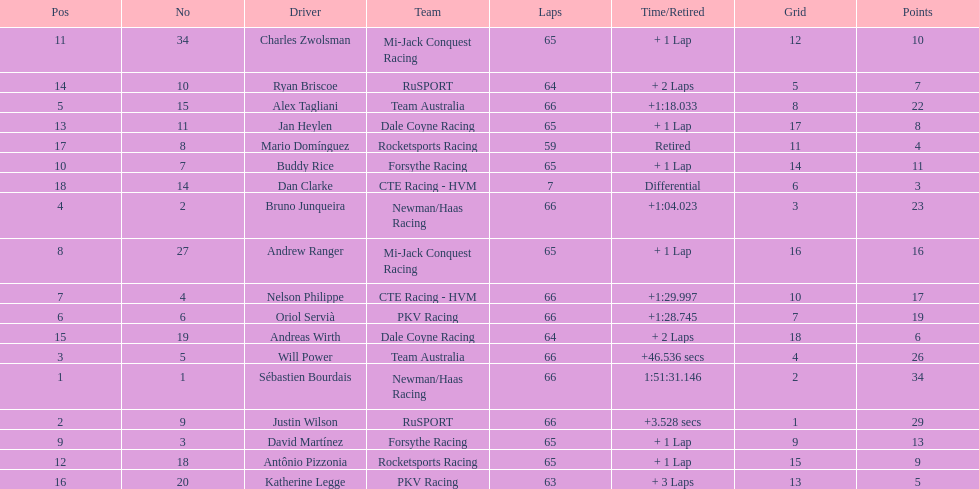Parse the table in full. {'header': ['Pos', 'No', 'Driver', 'Team', 'Laps', 'Time/Retired', 'Grid', 'Points'], 'rows': [['11', '34', 'Charles Zwolsman', 'Mi-Jack Conquest Racing', '65', '+ 1 Lap', '12', '10'], ['14', '10', 'Ryan Briscoe', 'RuSPORT', '64', '+ 2 Laps', '5', '7'], ['5', '15', 'Alex Tagliani', 'Team Australia', '66', '+1:18.033', '8', '22'], ['13', '11', 'Jan Heylen', 'Dale Coyne Racing', '65', '+ 1 Lap', '17', '8'], ['17', '8', 'Mario Domínguez', 'Rocketsports Racing', '59', 'Retired', '11', '4'], ['10', '7', 'Buddy Rice', 'Forsythe Racing', '65', '+ 1 Lap', '14', '11'], ['18', '14', 'Dan Clarke', 'CTE Racing - HVM', '7', 'Differential', '6', '3'], ['4', '2', 'Bruno Junqueira', 'Newman/Haas Racing', '66', '+1:04.023', '3', '23'], ['8', '27', 'Andrew Ranger', 'Mi-Jack Conquest Racing', '65', '+ 1 Lap', '16', '16'], ['7', '4', 'Nelson Philippe', 'CTE Racing - HVM', '66', '+1:29.997', '10', '17'], ['6', '6', 'Oriol Servià', 'PKV Racing', '66', '+1:28.745', '7', '19'], ['15', '19', 'Andreas Wirth', 'Dale Coyne Racing', '64', '+ 2 Laps', '18', '6'], ['3', '5', 'Will Power', 'Team Australia', '66', '+46.536 secs', '4', '26'], ['1', '1', 'Sébastien Bourdais', 'Newman/Haas Racing', '66', '1:51:31.146', '2', '34'], ['2', '9', 'Justin Wilson', 'RuSPORT', '66', '+3.528 secs', '1', '29'], ['9', '3', 'David Martínez', 'Forsythe Racing', '65', '+ 1 Lap', '9', '13'], ['12', '18', 'Antônio Pizzonia', 'Rocketsports Racing', '65', '+ 1 Lap', '15', '9'], ['16', '20', 'Katherine Legge', 'PKV Racing', '63', '+ 3 Laps', '13', '5']]} How many drivers did not make more than 60 laps? 2. 